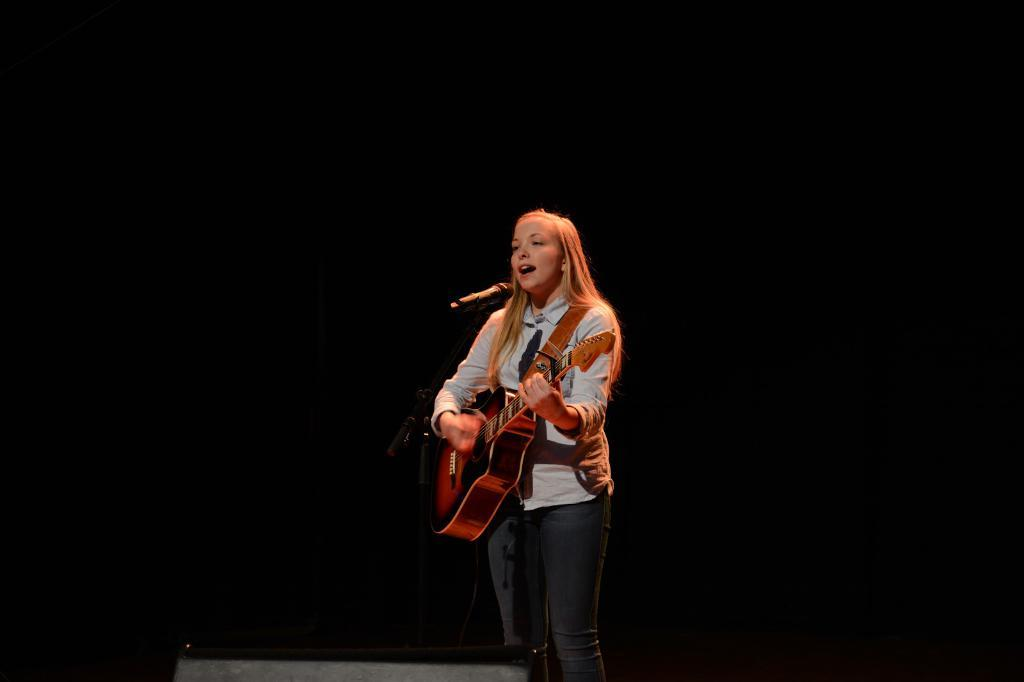Who is the main subject in the image? There is a woman in the image. What is the woman doing in the image? The woman is playing a guitar and singing. What object is present in the image that is typically used for amplifying sound? There is a microphone in the image. Can you hear the rabbit crying in the image? There is no rabbit or crying sound present in the image. 